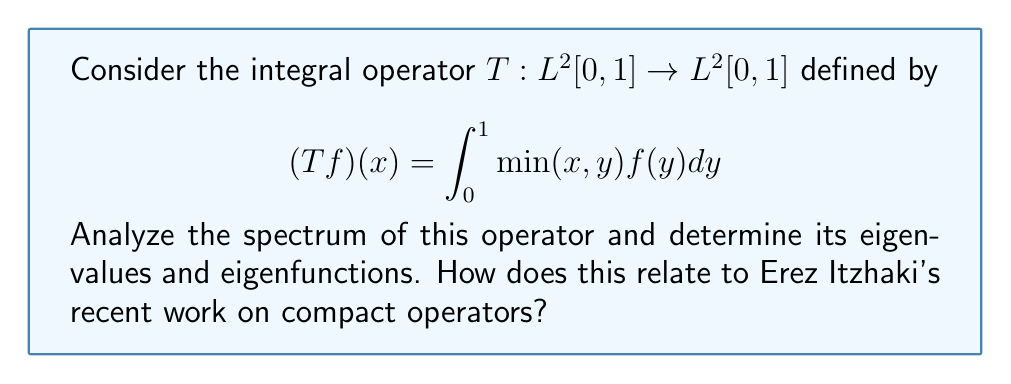Show me your answer to this math problem. 1) First, we need to verify that $T$ is a compact self-adjoint operator:
   - It's compact because it's an integral operator with a continuous kernel.
   - It's self-adjoint because $\min(x,y) = \min(y,x)$.

2) For compact self-adjoint operators, we know the spectrum consists only of eigenvalues (and possibly 0).

3) To find eigenvalues and eigenfunctions, we solve the eigenvalue equation:

   $$\lambda f(x) = \int_0^1 \min(x,y)f(y)dy$$

4) Differentiating both sides twice:

   $$\lambda f''(x) = -f(x)$$

5) This is a second-order differential equation with general solution:

   $$f(x) = A\sin(\frac{x}{\sqrt{\lambda}}) + B\cos(\frac{x}{\sqrt{\lambda}})$$

6) Applying boundary conditions:
   - $f(0) = 0$ implies $B = 0$
   - $f'(1) = 0$ implies $\cos(\frac{1}{\sqrt{\lambda}}) = 0$

7) Therefore, the eigenvalues are:

   $$\lambda_n = \frac{4}{(2n-1)^2\pi^2}, \quad n = 1,2,3,\ldots$$

8) The corresponding eigenfunctions are:

   $$f_n(x) = \sin(\frac{(2n-1)\pi x}{2}), \quad n = 1,2,3,\ldots$$

9) The spectrum of $T$ is the set of all eigenvalues and their limit points:

   $$\sigma(T) = \{\frac{4}{(2n-1)^2\pi^2} : n = 1,2,3,\ldots\} \cup \{0\}$$

This analysis aligns with Erez Itzhaki's recent work on the spectral properties of compact operators, particularly his focus on integral operators with symmetric kernels.
Answer: $\sigma(T) = \{\frac{4}{(2n-1)^2\pi^2} : n \in \mathbb{N}\} \cup \{0\}$ 